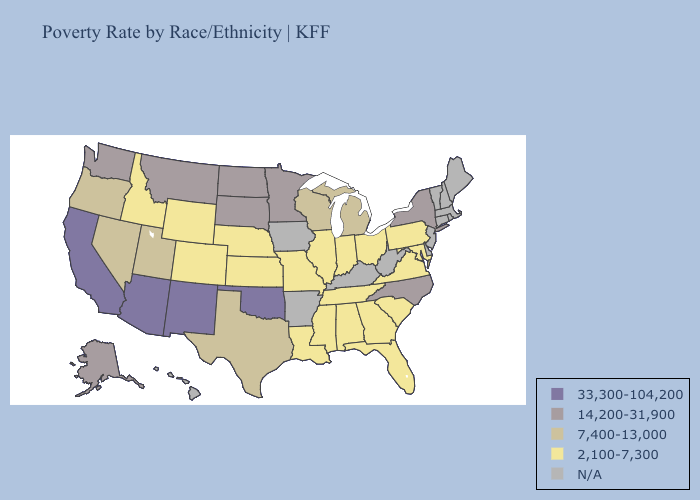What is the value of Arizona?
Quick response, please. 33,300-104,200. Among the states that border Virginia , does North Carolina have the lowest value?
Be succinct. No. Does South Carolina have the highest value in the USA?
Short answer required. No. Name the states that have a value in the range 33,300-104,200?
Give a very brief answer. Arizona, California, New Mexico, Oklahoma. Among the states that border Colorado , does Arizona have the highest value?
Be succinct. Yes. Which states have the highest value in the USA?
Answer briefly. Arizona, California, New Mexico, Oklahoma. What is the value of Indiana?
Keep it brief. 2,100-7,300. What is the value of Oregon?
Answer briefly. 7,400-13,000. Does Ohio have the highest value in the USA?
Be succinct. No. What is the value of North Carolina?
Concise answer only. 14,200-31,900. Which states have the lowest value in the USA?
Write a very short answer. Alabama, Colorado, Florida, Georgia, Idaho, Illinois, Indiana, Kansas, Louisiana, Maryland, Mississippi, Missouri, Nebraska, Ohio, Pennsylvania, South Carolina, Tennessee, Virginia, Wyoming. Is the legend a continuous bar?
Write a very short answer. No. What is the value of South Dakota?
Concise answer only. 14,200-31,900. Name the states that have a value in the range 14,200-31,900?
Answer briefly. Alaska, Minnesota, Montana, New York, North Carolina, North Dakota, South Dakota, Washington. 